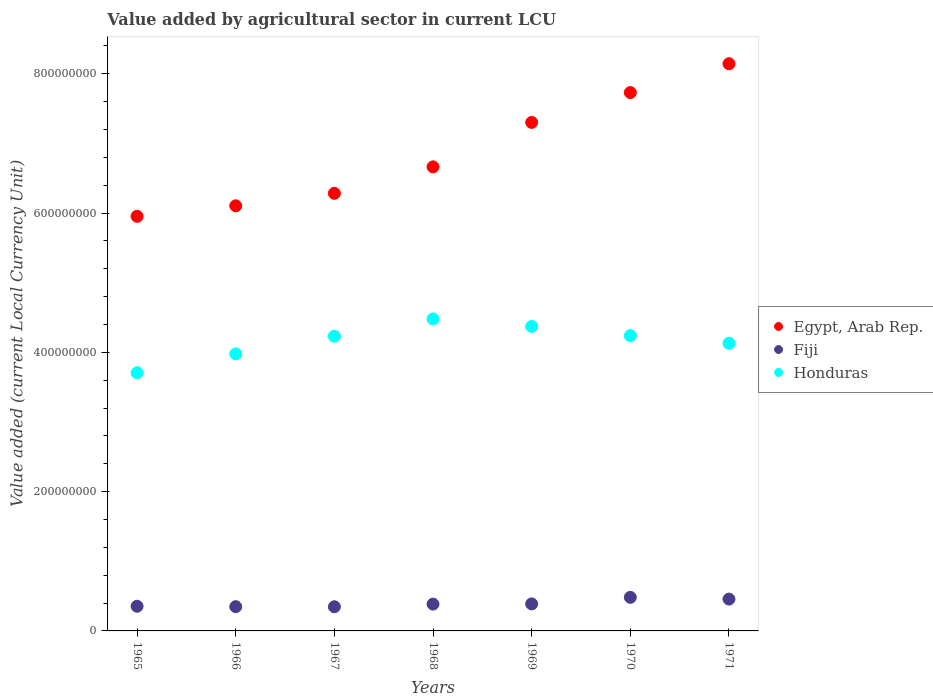How many different coloured dotlines are there?
Offer a very short reply. 3. What is the value added by agricultural sector in Fiji in 1971?
Offer a very short reply. 4.57e+07. Across all years, what is the maximum value added by agricultural sector in Fiji?
Keep it short and to the point. 4.82e+07. Across all years, what is the minimum value added by agricultural sector in Egypt, Arab Rep.?
Offer a terse response. 5.95e+08. In which year was the value added by agricultural sector in Egypt, Arab Rep. maximum?
Your answer should be compact. 1971. In which year was the value added by agricultural sector in Honduras minimum?
Your answer should be very brief. 1965. What is the total value added by agricultural sector in Fiji in the graph?
Your response must be concise. 2.76e+08. What is the difference between the value added by agricultural sector in Honduras in 1966 and that in 1969?
Make the answer very short. -3.94e+07. What is the difference between the value added by agricultural sector in Fiji in 1969 and the value added by agricultural sector in Egypt, Arab Rep. in 1965?
Offer a very short reply. -5.56e+08. What is the average value added by agricultural sector in Egypt, Arab Rep. per year?
Give a very brief answer. 6.88e+08. In the year 1967, what is the difference between the value added by agricultural sector in Honduras and value added by agricultural sector in Fiji?
Provide a succinct answer. 3.88e+08. What is the ratio of the value added by agricultural sector in Honduras in 1968 to that in 1970?
Ensure brevity in your answer.  1.06. Is the value added by agricultural sector in Egypt, Arab Rep. in 1968 less than that in 1970?
Provide a short and direct response. Yes. What is the difference between the highest and the second highest value added by agricultural sector in Egypt, Arab Rep.?
Your response must be concise. 4.14e+07. What is the difference between the highest and the lowest value added by agricultural sector in Egypt, Arab Rep.?
Your response must be concise. 2.19e+08. Is it the case that in every year, the sum of the value added by agricultural sector in Honduras and value added by agricultural sector in Egypt, Arab Rep.  is greater than the value added by agricultural sector in Fiji?
Provide a succinct answer. Yes. Does the value added by agricultural sector in Honduras monotonically increase over the years?
Offer a terse response. No. What is the difference between two consecutive major ticks on the Y-axis?
Offer a terse response. 2.00e+08. Are the values on the major ticks of Y-axis written in scientific E-notation?
Offer a very short reply. No. Where does the legend appear in the graph?
Ensure brevity in your answer.  Center right. How are the legend labels stacked?
Make the answer very short. Vertical. What is the title of the graph?
Offer a terse response. Value added by agricultural sector in current LCU. Does "Korea (Republic)" appear as one of the legend labels in the graph?
Give a very brief answer. No. What is the label or title of the Y-axis?
Ensure brevity in your answer.  Value added (current Local Currency Unit). What is the Value added (current Local Currency Unit) of Egypt, Arab Rep. in 1965?
Keep it short and to the point. 5.95e+08. What is the Value added (current Local Currency Unit) in Fiji in 1965?
Your response must be concise. 3.54e+07. What is the Value added (current Local Currency Unit) in Honduras in 1965?
Offer a very short reply. 3.71e+08. What is the Value added (current Local Currency Unit) in Egypt, Arab Rep. in 1966?
Your answer should be very brief. 6.10e+08. What is the Value added (current Local Currency Unit) of Fiji in 1966?
Give a very brief answer. 3.48e+07. What is the Value added (current Local Currency Unit) of Honduras in 1966?
Make the answer very short. 3.98e+08. What is the Value added (current Local Currency Unit) of Egypt, Arab Rep. in 1967?
Your answer should be compact. 6.28e+08. What is the Value added (current Local Currency Unit) in Fiji in 1967?
Make the answer very short. 3.47e+07. What is the Value added (current Local Currency Unit) of Honduras in 1967?
Your answer should be compact. 4.23e+08. What is the Value added (current Local Currency Unit) in Egypt, Arab Rep. in 1968?
Make the answer very short. 6.66e+08. What is the Value added (current Local Currency Unit) of Fiji in 1968?
Provide a short and direct response. 3.85e+07. What is the Value added (current Local Currency Unit) of Honduras in 1968?
Provide a short and direct response. 4.48e+08. What is the Value added (current Local Currency Unit) in Egypt, Arab Rep. in 1969?
Provide a succinct answer. 7.30e+08. What is the Value added (current Local Currency Unit) in Fiji in 1969?
Ensure brevity in your answer.  3.88e+07. What is the Value added (current Local Currency Unit) of Honduras in 1969?
Your answer should be compact. 4.37e+08. What is the Value added (current Local Currency Unit) of Egypt, Arab Rep. in 1970?
Provide a succinct answer. 7.73e+08. What is the Value added (current Local Currency Unit) in Fiji in 1970?
Offer a terse response. 4.82e+07. What is the Value added (current Local Currency Unit) of Honduras in 1970?
Your answer should be very brief. 4.24e+08. What is the Value added (current Local Currency Unit) in Egypt, Arab Rep. in 1971?
Ensure brevity in your answer.  8.14e+08. What is the Value added (current Local Currency Unit) of Fiji in 1971?
Your response must be concise. 4.57e+07. What is the Value added (current Local Currency Unit) of Honduras in 1971?
Your answer should be very brief. 4.13e+08. Across all years, what is the maximum Value added (current Local Currency Unit) of Egypt, Arab Rep.?
Provide a short and direct response. 8.14e+08. Across all years, what is the maximum Value added (current Local Currency Unit) in Fiji?
Provide a short and direct response. 4.82e+07. Across all years, what is the maximum Value added (current Local Currency Unit) of Honduras?
Offer a terse response. 4.48e+08. Across all years, what is the minimum Value added (current Local Currency Unit) in Egypt, Arab Rep.?
Provide a succinct answer. 5.95e+08. Across all years, what is the minimum Value added (current Local Currency Unit) of Fiji?
Make the answer very short. 3.47e+07. Across all years, what is the minimum Value added (current Local Currency Unit) in Honduras?
Your answer should be compact. 3.71e+08. What is the total Value added (current Local Currency Unit) of Egypt, Arab Rep. in the graph?
Your response must be concise. 4.82e+09. What is the total Value added (current Local Currency Unit) of Fiji in the graph?
Your answer should be compact. 2.76e+08. What is the total Value added (current Local Currency Unit) in Honduras in the graph?
Ensure brevity in your answer.  2.91e+09. What is the difference between the Value added (current Local Currency Unit) of Egypt, Arab Rep. in 1965 and that in 1966?
Ensure brevity in your answer.  -1.51e+07. What is the difference between the Value added (current Local Currency Unit) of Fiji in 1965 and that in 1966?
Your answer should be compact. 6.00e+05. What is the difference between the Value added (current Local Currency Unit) of Honduras in 1965 and that in 1966?
Ensure brevity in your answer.  -2.71e+07. What is the difference between the Value added (current Local Currency Unit) of Egypt, Arab Rep. in 1965 and that in 1967?
Keep it short and to the point. -3.30e+07. What is the difference between the Value added (current Local Currency Unit) in Fiji in 1965 and that in 1967?
Offer a very short reply. 7.00e+05. What is the difference between the Value added (current Local Currency Unit) in Honduras in 1965 and that in 1967?
Provide a short and direct response. -5.24e+07. What is the difference between the Value added (current Local Currency Unit) of Egypt, Arab Rep. in 1965 and that in 1968?
Provide a short and direct response. -7.10e+07. What is the difference between the Value added (current Local Currency Unit) in Fiji in 1965 and that in 1968?
Provide a short and direct response. -3.10e+06. What is the difference between the Value added (current Local Currency Unit) of Honduras in 1965 and that in 1968?
Your answer should be very brief. -7.73e+07. What is the difference between the Value added (current Local Currency Unit) of Egypt, Arab Rep. in 1965 and that in 1969?
Give a very brief answer. -1.35e+08. What is the difference between the Value added (current Local Currency Unit) of Fiji in 1965 and that in 1969?
Make the answer very short. -3.40e+06. What is the difference between the Value added (current Local Currency Unit) of Honduras in 1965 and that in 1969?
Offer a terse response. -6.65e+07. What is the difference between the Value added (current Local Currency Unit) of Egypt, Arab Rep. in 1965 and that in 1970?
Your response must be concise. -1.78e+08. What is the difference between the Value added (current Local Currency Unit) in Fiji in 1965 and that in 1970?
Offer a terse response. -1.28e+07. What is the difference between the Value added (current Local Currency Unit) of Honduras in 1965 and that in 1970?
Provide a succinct answer. -5.33e+07. What is the difference between the Value added (current Local Currency Unit) in Egypt, Arab Rep. in 1965 and that in 1971?
Keep it short and to the point. -2.19e+08. What is the difference between the Value added (current Local Currency Unit) of Fiji in 1965 and that in 1971?
Offer a very short reply. -1.03e+07. What is the difference between the Value added (current Local Currency Unit) in Honduras in 1965 and that in 1971?
Offer a very short reply. -4.23e+07. What is the difference between the Value added (current Local Currency Unit) in Egypt, Arab Rep. in 1966 and that in 1967?
Give a very brief answer. -1.79e+07. What is the difference between the Value added (current Local Currency Unit) in Honduras in 1966 and that in 1967?
Offer a very short reply. -2.53e+07. What is the difference between the Value added (current Local Currency Unit) of Egypt, Arab Rep. in 1966 and that in 1968?
Provide a succinct answer. -5.59e+07. What is the difference between the Value added (current Local Currency Unit) of Fiji in 1966 and that in 1968?
Provide a succinct answer. -3.70e+06. What is the difference between the Value added (current Local Currency Unit) in Honduras in 1966 and that in 1968?
Make the answer very short. -5.02e+07. What is the difference between the Value added (current Local Currency Unit) in Egypt, Arab Rep. in 1966 and that in 1969?
Provide a succinct answer. -1.20e+08. What is the difference between the Value added (current Local Currency Unit) of Honduras in 1966 and that in 1969?
Give a very brief answer. -3.94e+07. What is the difference between the Value added (current Local Currency Unit) of Egypt, Arab Rep. in 1966 and that in 1970?
Ensure brevity in your answer.  -1.63e+08. What is the difference between the Value added (current Local Currency Unit) in Fiji in 1966 and that in 1970?
Ensure brevity in your answer.  -1.34e+07. What is the difference between the Value added (current Local Currency Unit) of Honduras in 1966 and that in 1970?
Provide a succinct answer. -2.62e+07. What is the difference between the Value added (current Local Currency Unit) in Egypt, Arab Rep. in 1966 and that in 1971?
Keep it short and to the point. -2.04e+08. What is the difference between the Value added (current Local Currency Unit) in Fiji in 1966 and that in 1971?
Provide a succinct answer. -1.09e+07. What is the difference between the Value added (current Local Currency Unit) of Honduras in 1966 and that in 1971?
Keep it short and to the point. -1.52e+07. What is the difference between the Value added (current Local Currency Unit) of Egypt, Arab Rep. in 1967 and that in 1968?
Offer a very short reply. -3.80e+07. What is the difference between the Value added (current Local Currency Unit) in Fiji in 1967 and that in 1968?
Your answer should be very brief. -3.80e+06. What is the difference between the Value added (current Local Currency Unit) of Honduras in 1967 and that in 1968?
Your answer should be compact. -2.49e+07. What is the difference between the Value added (current Local Currency Unit) in Egypt, Arab Rep. in 1967 and that in 1969?
Provide a succinct answer. -1.02e+08. What is the difference between the Value added (current Local Currency Unit) of Fiji in 1967 and that in 1969?
Offer a very short reply. -4.10e+06. What is the difference between the Value added (current Local Currency Unit) in Honduras in 1967 and that in 1969?
Offer a very short reply. -1.41e+07. What is the difference between the Value added (current Local Currency Unit) in Egypt, Arab Rep. in 1967 and that in 1970?
Make the answer very short. -1.45e+08. What is the difference between the Value added (current Local Currency Unit) in Fiji in 1967 and that in 1970?
Offer a very short reply. -1.35e+07. What is the difference between the Value added (current Local Currency Unit) in Honduras in 1967 and that in 1970?
Provide a short and direct response. -9.00e+05. What is the difference between the Value added (current Local Currency Unit) in Egypt, Arab Rep. in 1967 and that in 1971?
Ensure brevity in your answer.  -1.86e+08. What is the difference between the Value added (current Local Currency Unit) in Fiji in 1967 and that in 1971?
Ensure brevity in your answer.  -1.10e+07. What is the difference between the Value added (current Local Currency Unit) of Honduras in 1967 and that in 1971?
Provide a succinct answer. 1.01e+07. What is the difference between the Value added (current Local Currency Unit) of Egypt, Arab Rep. in 1968 and that in 1969?
Your response must be concise. -6.38e+07. What is the difference between the Value added (current Local Currency Unit) of Fiji in 1968 and that in 1969?
Provide a short and direct response. -3.00e+05. What is the difference between the Value added (current Local Currency Unit) in Honduras in 1968 and that in 1969?
Your answer should be very brief. 1.08e+07. What is the difference between the Value added (current Local Currency Unit) of Egypt, Arab Rep. in 1968 and that in 1970?
Make the answer very short. -1.07e+08. What is the difference between the Value added (current Local Currency Unit) in Fiji in 1968 and that in 1970?
Provide a succinct answer. -9.70e+06. What is the difference between the Value added (current Local Currency Unit) of Honduras in 1968 and that in 1970?
Your answer should be very brief. 2.40e+07. What is the difference between the Value added (current Local Currency Unit) in Egypt, Arab Rep. in 1968 and that in 1971?
Your response must be concise. -1.48e+08. What is the difference between the Value added (current Local Currency Unit) in Fiji in 1968 and that in 1971?
Make the answer very short. -7.20e+06. What is the difference between the Value added (current Local Currency Unit) in Honduras in 1968 and that in 1971?
Your answer should be compact. 3.50e+07. What is the difference between the Value added (current Local Currency Unit) in Egypt, Arab Rep. in 1969 and that in 1970?
Keep it short and to the point. -4.29e+07. What is the difference between the Value added (current Local Currency Unit) in Fiji in 1969 and that in 1970?
Make the answer very short. -9.40e+06. What is the difference between the Value added (current Local Currency Unit) of Honduras in 1969 and that in 1970?
Make the answer very short. 1.32e+07. What is the difference between the Value added (current Local Currency Unit) in Egypt, Arab Rep. in 1969 and that in 1971?
Make the answer very short. -8.43e+07. What is the difference between the Value added (current Local Currency Unit) of Fiji in 1969 and that in 1971?
Offer a very short reply. -6.90e+06. What is the difference between the Value added (current Local Currency Unit) of Honduras in 1969 and that in 1971?
Make the answer very short. 2.42e+07. What is the difference between the Value added (current Local Currency Unit) in Egypt, Arab Rep. in 1970 and that in 1971?
Provide a succinct answer. -4.14e+07. What is the difference between the Value added (current Local Currency Unit) of Fiji in 1970 and that in 1971?
Provide a succinct answer. 2.50e+06. What is the difference between the Value added (current Local Currency Unit) of Honduras in 1970 and that in 1971?
Provide a succinct answer. 1.10e+07. What is the difference between the Value added (current Local Currency Unit) of Egypt, Arab Rep. in 1965 and the Value added (current Local Currency Unit) of Fiji in 1966?
Keep it short and to the point. 5.60e+08. What is the difference between the Value added (current Local Currency Unit) of Egypt, Arab Rep. in 1965 and the Value added (current Local Currency Unit) of Honduras in 1966?
Give a very brief answer. 1.98e+08. What is the difference between the Value added (current Local Currency Unit) in Fiji in 1965 and the Value added (current Local Currency Unit) in Honduras in 1966?
Your response must be concise. -3.62e+08. What is the difference between the Value added (current Local Currency Unit) of Egypt, Arab Rep. in 1965 and the Value added (current Local Currency Unit) of Fiji in 1967?
Offer a very short reply. 5.61e+08. What is the difference between the Value added (current Local Currency Unit) of Egypt, Arab Rep. in 1965 and the Value added (current Local Currency Unit) of Honduras in 1967?
Provide a succinct answer. 1.72e+08. What is the difference between the Value added (current Local Currency Unit) of Fiji in 1965 and the Value added (current Local Currency Unit) of Honduras in 1967?
Your response must be concise. -3.88e+08. What is the difference between the Value added (current Local Currency Unit) in Egypt, Arab Rep. in 1965 and the Value added (current Local Currency Unit) in Fiji in 1968?
Provide a short and direct response. 5.57e+08. What is the difference between the Value added (current Local Currency Unit) in Egypt, Arab Rep. in 1965 and the Value added (current Local Currency Unit) in Honduras in 1968?
Your answer should be compact. 1.47e+08. What is the difference between the Value added (current Local Currency Unit) in Fiji in 1965 and the Value added (current Local Currency Unit) in Honduras in 1968?
Offer a very short reply. -4.13e+08. What is the difference between the Value added (current Local Currency Unit) in Egypt, Arab Rep. in 1965 and the Value added (current Local Currency Unit) in Fiji in 1969?
Make the answer very short. 5.56e+08. What is the difference between the Value added (current Local Currency Unit) in Egypt, Arab Rep. in 1965 and the Value added (current Local Currency Unit) in Honduras in 1969?
Ensure brevity in your answer.  1.58e+08. What is the difference between the Value added (current Local Currency Unit) in Fiji in 1965 and the Value added (current Local Currency Unit) in Honduras in 1969?
Make the answer very short. -4.02e+08. What is the difference between the Value added (current Local Currency Unit) of Egypt, Arab Rep. in 1965 and the Value added (current Local Currency Unit) of Fiji in 1970?
Your response must be concise. 5.47e+08. What is the difference between the Value added (current Local Currency Unit) in Egypt, Arab Rep. in 1965 and the Value added (current Local Currency Unit) in Honduras in 1970?
Keep it short and to the point. 1.71e+08. What is the difference between the Value added (current Local Currency Unit) in Fiji in 1965 and the Value added (current Local Currency Unit) in Honduras in 1970?
Offer a very short reply. -3.89e+08. What is the difference between the Value added (current Local Currency Unit) of Egypt, Arab Rep. in 1965 and the Value added (current Local Currency Unit) of Fiji in 1971?
Give a very brief answer. 5.50e+08. What is the difference between the Value added (current Local Currency Unit) of Egypt, Arab Rep. in 1965 and the Value added (current Local Currency Unit) of Honduras in 1971?
Give a very brief answer. 1.82e+08. What is the difference between the Value added (current Local Currency Unit) in Fiji in 1965 and the Value added (current Local Currency Unit) in Honduras in 1971?
Your answer should be very brief. -3.78e+08. What is the difference between the Value added (current Local Currency Unit) of Egypt, Arab Rep. in 1966 and the Value added (current Local Currency Unit) of Fiji in 1967?
Your answer should be compact. 5.76e+08. What is the difference between the Value added (current Local Currency Unit) in Egypt, Arab Rep. in 1966 and the Value added (current Local Currency Unit) in Honduras in 1967?
Offer a very short reply. 1.87e+08. What is the difference between the Value added (current Local Currency Unit) in Fiji in 1966 and the Value added (current Local Currency Unit) in Honduras in 1967?
Provide a succinct answer. -3.88e+08. What is the difference between the Value added (current Local Currency Unit) in Egypt, Arab Rep. in 1966 and the Value added (current Local Currency Unit) in Fiji in 1968?
Provide a succinct answer. 5.72e+08. What is the difference between the Value added (current Local Currency Unit) in Egypt, Arab Rep. in 1966 and the Value added (current Local Currency Unit) in Honduras in 1968?
Your answer should be very brief. 1.62e+08. What is the difference between the Value added (current Local Currency Unit) of Fiji in 1966 and the Value added (current Local Currency Unit) of Honduras in 1968?
Keep it short and to the point. -4.13e+08. What is the difference between the Value added (current Local Currency Unit) of Egypt, Arab Rep. in 1966 and the Value added (current Local Currency Unit) of Fiji in 1969?
Offer a very short reply. 5.72e+08. What is the difference between the Value added (current Local Currency Unit) in Egypt, Arab Rep. in 1966 and the Value added (current Local Currency Unit) in Honduras in 1969?
Ensure brevity in your answer.  1.73e+08. What is the difference between the Value added (current Local Currency Unit) in Fiji in 1966 and the Value added (current Local Currency Unit) in Honduras in 1969?
Offer a very short reply. -4.02e+08. What is the difference between the Value added (current Local Currency Unit) in Egypt, Arab Rep. in 1966 and the Value added (current Local Currency Unit) in Fiji in 1970?
Keep it short and to the point. 5.62e+08. What is the difference between the Value added (current Local Currency Unit) in Egypt, Arab Rep. in 1966 and the Value added (current Local Currency Unit) in Honduras in 1970?
Your answer should be compact. 1.86e+08. What is the difference between the Value added (current Local Currency Unit) of Fiji in 1966 and the Value added (current Local Currency Unit) of Honduras in 1970?
Your answer should be very brief. -3.89e+08. What is the difference between the Value added (current Local Currency Unit) of Egypt, Arab Rep. in 1966 and the Value added (current Local Currency Unit) of Fiji in 1971?
Give a very brief answer. 5.65e+08. What is the difference between the Value added (current Local Currency Unit) in Egypt, Arab Rep. in 1966 and the Value added (current Local Currency Unit) in Honduras in 1971?
Give a very brief answer. 1.97e+08. What is the difference between the Value added (current Local Currency Unit) in Fiji in 1966 and the Value added (current Local Currency Unit) in Honduras in 1971?
Keep it short and to the point. -3.78e+08. What is the difference between the Value added (current Local Currency Unit) in Egypt, Arab Rep. in 1967 and the Value added (current Local Currency Unit) in Fiji in 1968?
Your response must be concise. 5.90e+08. What is the difference between the Value added (current Local Currency Unit) of Egypt, Arab Rep. in 1967 and the Value added (current Local Currency Unit) of Honduras in 1968?
Your response must be concise. 1.80e+08. What is the difference between the Value added (current Local Currency Unit) in Fiji in 1967 and the Value added (current Local Currency Unit) in Honduras in 1968?
Keep it short and to the point. -4.13e+08. What is the difference between the Value added (current Local Currency Unit) of Egypt, Arab Rep. in 1967 and the Value added (current Local Currency Unit) of Fiji in 1969?
Offer a very short reply. 5.90e+08. What is the difference between the Value added (current Local Currency Unit) of Egypt, Arab Rep. in 1967 and the Value added (current Local Currency Unit) of Honduras in 1969?
Keep it short and to the point. 1.91e+08. What is the difference between the Value added (current Local Currency Unit) of Fiji in 1967 and the Value added (current Local Currency Unit) of Honduras in 1969?
Make the answer very short. -4.02e+08. What is the difference between the Value added (current Local Currency Unit) of Egypt, Arab Rep. in 1967 and the Value added (current Local Currency Unit) of Fiji in 1970?
Ensure brevity in your answer.  5.80e+08. What is the difference between the Value added (current Local Currency Unit) in Egypt, Arab Rep. in 1967 and the Value added (current Local Currency Unit) in Honduras in 1970?
Your response must be concise. 2.04e+08. What is the difference between the Value added (current Local Currency Unit) in Fiji in 1967 and the Value added (current Local Currency Unit) in Honduras in 1970?
Give a very brief answer. -3.89e+08. What is the difference between the Value added (current Local Currency Unit) of Egypt, Arab Rep. in 1967 and the Value added (current Local Currency Unit) of Fiji in 1971?
Your answer should be very brief. 5.83e+08. What is the difference between the Value added (current Local Currency Unit) of Egypt, Arab Rep. in 1967 and the Value added (current Local Currency Unit) of Honduras in 1971?
Provide a short and direct response. 2.15e+08. What is the difference between the Value added (current Local Currency Unit) in Fiji in 1967 and the Value added (current Local Currency Unit) in Honduras in 1971?
Your answer should be very brief. -3.78e+08. What is the difference between the Value added (current Local Currency Unit) in Egypt, Arab Rep. in 1968 and the Value added (current Local Currency Unit) in Fiji in 1969?
Keep it short and to the point. 6.28e+08. What is the difference between the Value added (current Local Currency Unit) in Egypt, Arab Rep. in 1968 and the Value added (current Local Currency Unit) in Honduras in 1969?
Offer a very short reply. 2.29e+08. What is the difference between the Value added (current Local Currency Unit) in Fiji in 1968 and the Value added (current Local Currency Unit) in Honduras in 1969?
Offer a terse response. -3.99e+08. What is the difference between the Value added (current Local Currency Unit) in Egypt, Arab Rep. in 1968 and the Value added (current Local Currency Unit) in Fiji in 1970?
Ensure brevity in your answer.  6.18e+08. What is the difference between the Value added (current Local Currency Unit) in Egypt, Arab Rep. in 1968 and the Value added (current Local Currency Unit) in Honduras in 1970?
Make the answer very short. 2.42e+08. What is the difference between the Value added (current Local Currency Unit) of Fiji in 1968 and the Value added (current Local Currency Unit) of Honduras in 1970?
Provide a succinct answer. -3.86e+08. What is the difference between the Value added (current Local Currency Unit) in Egypt, Arab Rep. in 1968 and the Value added (current Local Currency Unit) in Fiji in 1971?
Keep it short and to the point. 6.21e+08. What is the difference between the Value added (current Local Currency Unit) of Egypt, Arab Rep. in 1968 and the Value added (current Local Currency Unit) of Honduras in 1971?
Offer a very short reply. 2.53e+08. What is the difference between the Value added (current Local Currency Unit) in Fiji in 1968 and the Value added (current Local Currency Unit) in Honduras in 1971?
Your answer should be compact. -3.74e+08. What is the difference between the Value added (current Local Currency Unit) in Egypt, Arab Rep. in 1969 and the Value added (current Local Currency Unit) in Fiji in 1970?
Provide a succinct answer. 6.82e+08. What is the difference between the Value added (current Local Currency Unit) in Egypt, Arab Rep. in 1969 and the Value added (current Local Currency Unit) in Honduras in 1970?
Ensure brevity in your answer.  3.06e+08. What is the difference between the Value added (current Local Currency Unit) in Fiji in 1969 and the Value added (current Local Currency Unit) in Honduras in 1970?
Provide a succinct answer. -3.85e+08. What is the difference between the Value added (current Local Currency Unit) of Egypt, Arab Rep. in 1969 and the Value added (current Local Currency Unit) of Fiji in 1971?
Your answer should be compact. 6.84e+08. What is the difference between the Value added (current Local Currency Unit) of Egypt, Arab Rep. in 1969 and the Value added (current Local Currency Unit) of Honduras in 1971?
Provide a succinct answer. 3.17e+08. What is the difference between the Value added (current Local Currency Unit) in Fiji in 1969 and the Value added (current Local Currency Unit) in Honduras in 1971?
Make the answer very short. -3.74e+08. What is the difference between the Value added (current Local Currency Unit) in Egypt, Arab Rep. in 1970 and the Value added (current Local Currency Unit) in Fiji in 1971?
Your answer should be very brief. 7.27e+08. What is the difference between the Value added (current Local Currency Unit) of Egypt, Arab Rep. in 1970 and the Value added (current Local Currency Unit) of Honduras in 1971?
Offer a very short reply. 3.60e+08. What is the difference between the Value added (current Local Currency Unit) of Fiji in 1970 and the Value added (current Local Currency Unit) of Honduras in 1971?
Your answer should be very brief. -3.65e+08. What is the average Value added (current Local Currency Unit) of Egypt, Arab Rep. per year?
Your answer should be very brief. 6.88e+08. What is the average Value added (current Local Currency Unit) in Fiji per year?
Offer a terse response. 3.94e+07. What is the average Value added (current Local Currency Unit) in Honduras per year?
Offer a very short reply. 4.16e+08. In the year 1965, what is the difference between the Value added (current Local Currency Unit) in Egypt, Arab Rep. and Value added (current Local Currency Unit) in Fiji?
Offer a very short reply. 5.60e+08. In the year 1965, what is the difference between the Value added (current Local Currency Unit) in Egypt, Arab Rep. and Value added (current Local Currency Unit) in Honduras?
Your response must be concise. 2.25e+08. In the year 1965, what is the difference between the Value added (current Local Currency Unit) of Fiji and Value added (current Local Currency Unit) of Honduras?
Provide a short and direct response. -3.35e+08. In the year 1966, what is the difference between the Value added (current Local Currency Unit) of Egypt, Arab Rep. and Value added (current Local Currency Unit) of Fiji?
Offer a terse response. 5.76e+08. In the year 1966, what is the difference between the Value added (current Local Currency Unit) in Egypt, Arab Rep. and Value added (current Local Currency Unit) in Honduras?
Offer a very short reply. 2.13e+08. In the year 1966, what is the difference between the Value added (current Local Currency Unit) of Fiji and Value added (current Local Currency Unit) of Honduras?
Offer a very short reply. -3.63e+08. In the year 1967, what is the difference between the Value added (current Local Currency Unit) of Egypt, Arab Rep. and Value added (current Local Currency Unit) of Fiji?
Give a very brief answer. 5.94e+08. In the year 1967, what is the difference between the Value added (current Local Currency Unit) of Egypt, Arab Rep. and Value added (current Local Currency Unit) of Honduras?
Ensure brevity in your answer.  2.05e+08. In the year 1967, what is the difference between the Value added (current Local Currency Unit) of Fiji and Value added (current Local Currency Unit) of Honduras?
Offer a very short reply. -3.88e+08. In the year 1968, what is the difference between the Value added (current Local Currency Unit) in Egypt, Arab Rep. and Value added (current Local Currency Unit) in Fiji?
Provide a succinct answer. 6.28e+08. In the year 1968, what is the difference between the Value added (current Local Currency Unit) of Egypt, Arab Rep. and Value added (current Local Currency Unit) of Honduras?
Your answer should be very brief. 2.18e+08. In the year 1968, what is the difference between the Value added (current Local Currency Unit) in Fiji and Value added (current Local Currency Unit) in Honduras?
Ensure brevity in your answer.  -4.10e+08. In the year 1969, what is the difference between the Value added (current Local Currency Unit) in Egypt, Arab Rep. and Value added (current Local Currency Unit) in Fiji?
Ensure brevity in your answer.  6.91e+08. In the year 1969, what is the difference between the Value added (current Local Currency Unit) of Egypt, Arab Rep. and Value added (current Local Currency Unit) of Honduras?
Your answer should be very brief. 2.93e+08. In the year 1969, what is the difference between the Value added (current Local Currency Unit) of Fiji and Value added (current Local Currency Unit) of Honduras?
Provide a short and direct response. -3.98e+08. In the year 1970, what is the difference between the Value added (current Local Currency Unit) in Egypt, Arab Rep. and Value added (current Local Currency Unit) in Fiji?
Offer a terse response. 7.25e+08. In the year 1970, what is the difference between the Value added (current Local Currency Unit) in Egypt, Arab Rep. and Value added (current Local Currency Unit) in Honduras?
Provide a succinct answer. 3.49e+08. In the year 1970, what is the difference between the Value added (current Local Currency Unit) of Fiji and Value added (current Local Currency Unit) of Honduras?
Your answer should be compact. -3.76e+08. In the year 1971, what is the difference between the Value added (current Local Currency Unit) of Egypt, Arab Rep. and Value added (current Local Currency Unit) of Fiji?
Offer a terse response. 7.69e+08. In the year 1971, what is the difference between the Value added (current Local Currency Unit) in Egypt, Arab Rep. and Value added (current Local Currency Unit) in Honduras?
Keep it short and to the point. 4.01e+08. In the year 1971, what is the difference between the Value added (current Local Currency Unit) of Fiji and Value added (current Local Currency Unit) of Honduras?
Offer a terse response. -3.67e+08. What is the ratio of the Value added (current Local Currency Unit) in Egypt, Arab Rep. in 1965 to that in 1966?
Give a very brief answer. 0.98. What is the ratio of the Value added (current Local Currency Unit) in Fiji in 1965 to that in 1966?
Provide a succinct answer. 1.02. What is the ratio of the Value added (current Local Currency Unit) in Honduras in 1965 to that in 1966?
Provide a short and direct response. 0.93. What is the ratio of the Value added (current Local Currency Unit) in Egypt, Arab Rep. in 1965 to that in 1967?
Provide a succinct answer. 0.95. What is the ratio of the Value added (current Local Currency Unit) in Fiji in 1965 to that in 1967?
Provide a succinct answer. 1.02. What is the ratio of the Value added (current Local Currency Unit) of Honduras in 1965 to that in 1967?
Offer a terse response. 0.88. What is the ratio of the Value added (current Local Currency Unit) of Egypt, Arab Rep. in 1965 to that in 1968?
Your answer should be very brief. 0.89. What is the ratio of the Value added (current Local Currency Unit) of Fiji in 1965 to that in 1968?
Your answer should be very brief. 0.92. What is the ratio of the Value added (current Local Currency Unit) in Honduras in 1965 to that in 1968?
Make the answer very short. 0.83. What is the ratio of the Value added (current Local Currency Unit) of Egypt, Arab Rep. in 1965 to that in 1969?
Ensure brevity in your answer.  0.82. What is the ratio of the Value added (current Local Currency Unit) of Fiji in 1965 to that in 1969?
Offer a very short reply. 0.91. What is the ratio of the Value added (current Local Currency Unit) in Honduras in 1965 to that in 1969?
Give a very brief answer. 0.85. What is the ratio of the Value added (current Local Currency Unit) of Egypt, Arab Rep. in 1965 to that in 1970?
Keep it short and to the point. 0.77. What is the ratio of the Value added (current Local Currency Unit) of Fiji in 1965 to that in 1970?
Offer a very short reply. 0.73. What is the ratio of the Value added (current Local Currency Unit) of Honduras in 1965 to that in 1970?
Provide a short and direct response. 0.87. What is the ratio of the Value added (current Local Currency Unit) of Egypt, Arab Rep. in 1965 to that in 1971?
Offer a very short reply. 0.73. What is the ratio of the Value added (current Local Currency Unit) of Fiji in 1965 to that in 1971?
Make the answer very short. 0.77. What is the ratio of the Value added (current Local Currency Unit) of Honduras in 1965 to that in 1971?
Keep it short and to the point. 0.9. What is the ratio of the Value added (current Local Currency Unit) of Egypt, Arab Rep. in 1966 to that in 1967?
Your answer should be very brief. 0.97. What is the ratio of the Value added (current Local Currency Unit) in Honduras in 1966 to that in 1967?
Give a very brief answer. 0.94. What is the ratio of the Value added (current Local Currency Unit) in Egypt, Arab Rep. in 1966 to that in 1968?
Your response must be concise. 0.92. What is the ratio of the Value added (current Local Currency Unit) of Fiji in 1966 to that in 1968?
Your answer should be very brief. 0.9. What is the ratio of the Value added (current Local Currency Unit) in Honduras in 1966 to that in 1968?
Your answer should be very brief. 0.89. What is the ratio of the Value added (current Local Currency Unit) in Egypt, Arab Rep. in 1966 to that in 1969?
Ensure brevity in your answer.  0.84. What is the ratio of the Value added (current Local Currency Unit) in Fiji in 1966 to that in 1969?
Your answer should be very brief. 0.9. What is the ratio of the Value added (current Local Currency Unit) of Honduras in 1966 to that in 1969?
Provide a short and direct response. 0.91. What is the ratio of the Value added (current Local Currency Unit) of Egypt, Arab Rep. in 1966 to that in 1970?
Make the answer very short. 0.79. What is the ratio of the Value added (current Local Currency Unit) in Fiji in 1966 to that in 1970?
Offer a very short reply. 0.72. What is the ratio of the Value added (current Local Currency Unit) in Honduras in 1966 to that in 1970?
Make the answer very short. 0.94. What is the ratio of the Value added (current Local Currency Unit) of Egypt, Arab Rep. in 1966 to that in 1971?
Keep it short and to the point. 0.75. What is the ratio of the Value added (current Local Currency Unit) in Fiji in 1966 to that in 1971?
Make the answer very short. 0.76. What is the ratio of the Value added (current Local Currency Unit) in Honduras in 1966 to that in 1971?
Keep it short and to the point. 0.96. What is the ratio of the Value added (current Local Currency Unit) of Egypt, Arab Rep. in 1967 to that in 1968?
Offer a terse response. 0.94. What is the ratio of the Value added (current Local Currency Unit) of Fiji in 1967 to that in 1968?
Provide a succinct answer. 0.9. What is the ratio of the Value added (current Local Currency Unit) in Egypt, Arab Rep. in 1967 to that in 1969?
Offer a terse response. 0.86. What is the ratio of the Value added (current Local Currency Unit) in Fiji in 1967 to that in 1969?
Offer a very short reply. 0.89. What is the ratio of the Value added (current Local Currency Unit) of Honduras in 1967 to that in 1969?
Offer a terse response. 0.97. What is the ratio of the Value added (current Local Currency Unit) of Egypt, Arab Rep. in 1967 to that in 1970?
Provide a short and direct response. 0.81. What is the ratio of the Value added (current Local Currency Unit) of Fiji in 1967 to that in 1970?
Ensure brevity in your answer.  0.72. What is the ratio of the Value added (current Local Currency Unit) of Honduras in 1967 to that in 1970?
Give a very brief answer. 1. What is the ratio of the Value added (current Local Currency Unit) in Egypt, Arab Rep. in 1967 to that in 1971?
Provide a short and direct response. 0.77. What is the ratio of the Value added (current Local Currency Unit) of Fiji in 1967 to that in 1971?
Make the answer very short. 0.76. What is the ratio of the Value added (current Local Currency Unit) in Honduras in 1967 to that in 1971?
Ensure brevity in your answer.  1.02. What is the ratio of the Value added (current Local Currency Unit) in Egypt, Arab Rep. in 1968 to that in 1969?
Provide a succinct answer. 0.91. What is the ratio of the Value added (current Local Currency Unit) of Honduras in 1968 to that in 1969?
Provide a short and direct response. 1.02. What is the ratio of the Value added (current Local Currency Unit) of Egypt, Arab Rep. in 1968 to that in 1970?
Provide a short and direct response. 0.86. What is the ratio of the Value added (current Local Currency Unit) in Fiji in 1968 to that in 1970?
Provide a short and direct response. 0.8. What is the ratio of the Value added (current Local Currency Unit) of Honduras in 1968 to that in 1970?
Provide a short and direct response. 1.06. What is the ratio of the Value added (current Local Currency Unit) of Egypt, Arab Rep. in 1968 to that in 1971?
Your response must be concise. 0.82. What is the ratio of the Value added (current Local Currency Unit) in Fiji in 1968 to that in 1971?
Provide a succinct answer. 0.84. What is the ratio of the Value added (current Local Currency Unit) in Honduras in 1968 to that in 1971?
Your answer should be compact. 1.08. What is the ratio of the Value added (current Local Currency Unit) in Egypt, Arab Rep. in 1969 to that in 1970?
Ensure brevity in your answer.  0.94. What is the ratio of the Value added (current Local Currency Unit) in Fiji in 1969 to that in 1970?
Ensure brevity in your answer.  0.81. What is the ratio of the Value added (current Local Currency Unit) of Honduras in 1969 to that in 1970?
Offer a very short reply. 1.03. What is the ratio of the Value added (current Local Currency Unit) of Egypt, Arab Rep. in 1969 to that in 1971?
Your response must be concise. 0.9. What is the ratio of the Value added (current Local Currency Unit) of Fiji in 1969 to that in 1971?
Offer a very short reply. 0.85. What is the ratio of the Value added (current Local Currency Unit) in Honduras in 1969 to that in 1971?
Ensure brevity in your answer.  1.06. What is the ratio of the Value added (current Local Currency Unit) of Egypt, Arab Rep. in 1970 to that in 1971?
Offer a terse response. 0.95. What is the ratio of the Value added (current Local Currency Unit) of Fiji in 1970 to that in 1971?
Offer a very short reply. 1.05. What is the ratio of the Value added (current Local Currency Unit) of Honduras in 1970 to that in 1971?
Ensure brevity in your answer.  1.03. What is the difference between the highest and the second highest Value added (current Local Currency Unit) of Egypt, Arab Rep.?
Make the answer very short. 4.14e+07. What is the difference between the highest and the second highest Value added (current Local Currency Unit) of Fiji?
Offer a very short reply. 2.50e+06. What is the difference between the highest and the second highest Value added (current Local Currency Unit) of Honduras?
Your answer should be very brief. 1.08e+07. What is the difference between the highest and the lowest Value added (current Local Currency Unit) in Egypt, Arab Rep.?
Offer a very short reply. 2.19e+08. What is the difference between the highest and the lowest Value added (current Local Currency Unit) of Fiji?
Your answer should be very brief. 1.35e+07. What is the difference between the highest and the lowest Value added (current Local Currency Unit) in Honduras?
Your answer should be very brief. 7.73e+07. 